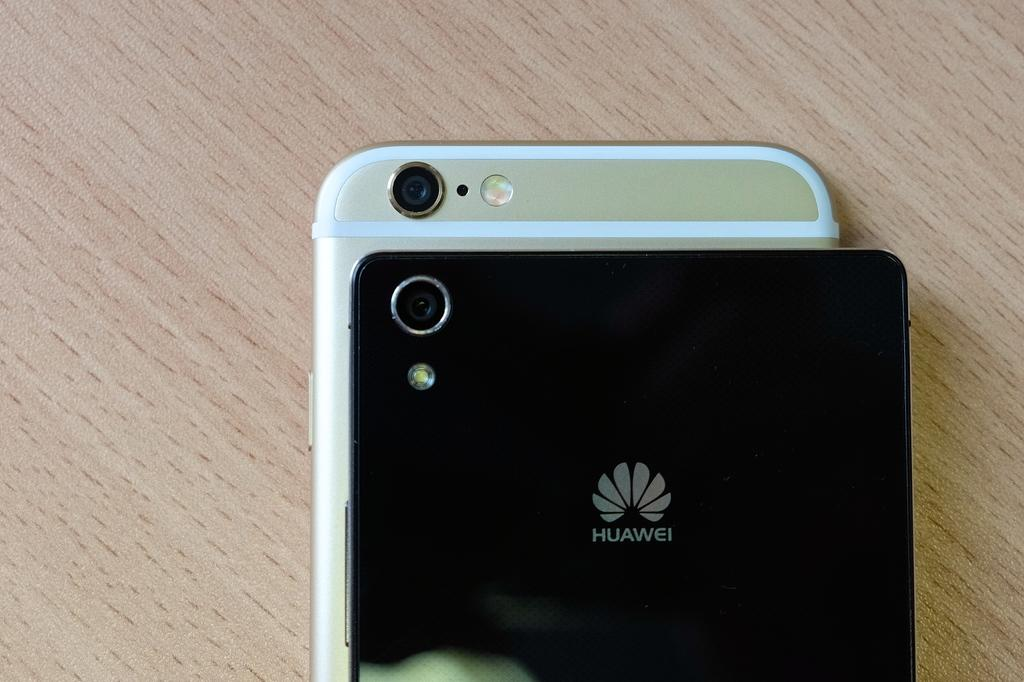Provide a one-sentence caption for the provided image. A black Huawei cell phone lies on top of another cell phone. 